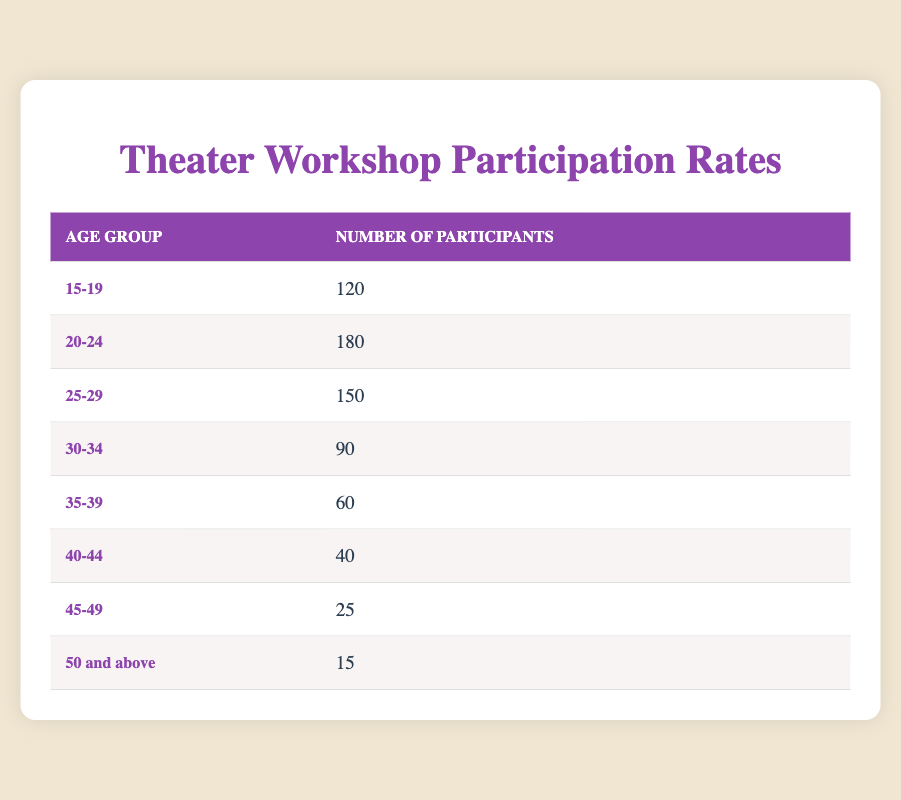What is the age group with the highest number of participants? The table shows that the age group "20-24" has 180 participants, which is more than any other age group listed, making it the highest.
Answer: 20-24 How many participants are there in the age group 30-34? The table directly lists the participants in the "30-34" age group as 90.
Answer: 90 Which age group has the least number of participants? By comparing all age groups, it's clear that the "50 and above" group has the fewest participants with only 15.
Answer: 50 and above What is the total number of participants from the age groups 15-19 and 20-24 combined? To find the total, add the number of participants in both groups: 120 (15-19) + 180 (20-24) = 300.
Answer: 300 Is it true that more participants are in the age group 25-29 than in the age group 35-39? Yes, the "25-29" age group has 150 participants, while the "35-39" age group has only 60, confirming the statement as true.
Answer: Yes What is the average number of participants across all age groups? First, sum all participants: 120 + 180 + 150 + 90 + 60 + 40 + 25 + 15 = 670. There are 8 age groups. The average is then 670/8 = 83.75.
Answer: 83.75 How many more participants are in the age group 40-44 than in the age group 45-49? Subtract the number of participants in the "45-49" age group (25) from the "40-44" age group (40): 40 - 25 = 15.
Answer: 15 What percentage of participants are aged 30 and above? First, sum the participants aged 30 and above: 90 (30-34) + 60 (35-39) + 40 (40-44) + 25 (45-49) + 15 (50 and above) = 230. The total number of participants is 670. The percentage is (230/670) × 100 = 34.33%.
Answer: 34.33% 